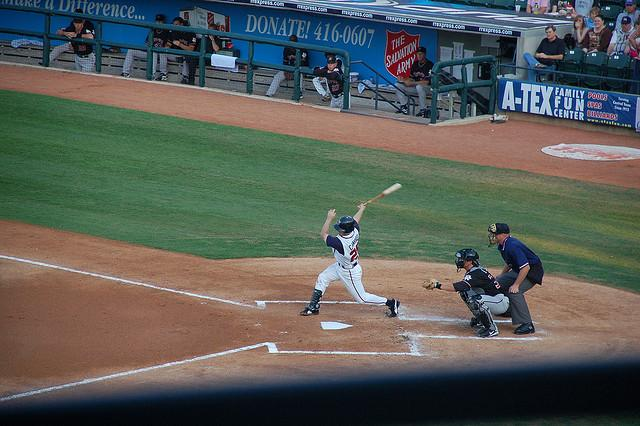Who is the man crouched behind the catcher? umpire 